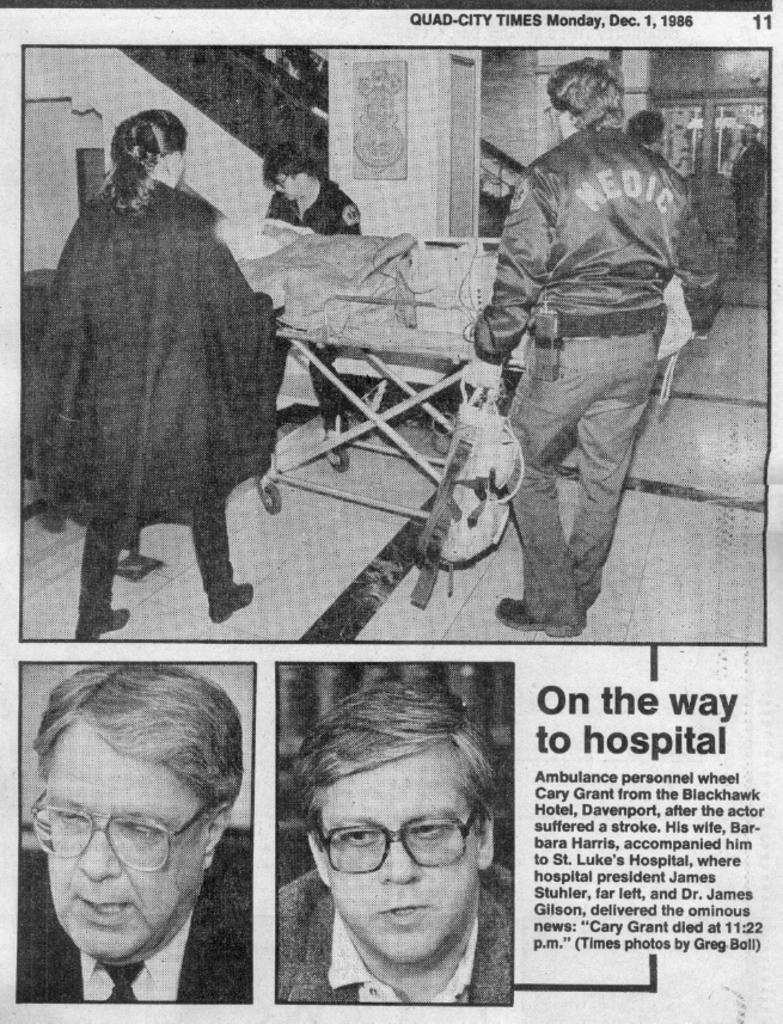Where does the article say they are going?
Offer a terse response. Hospital. 